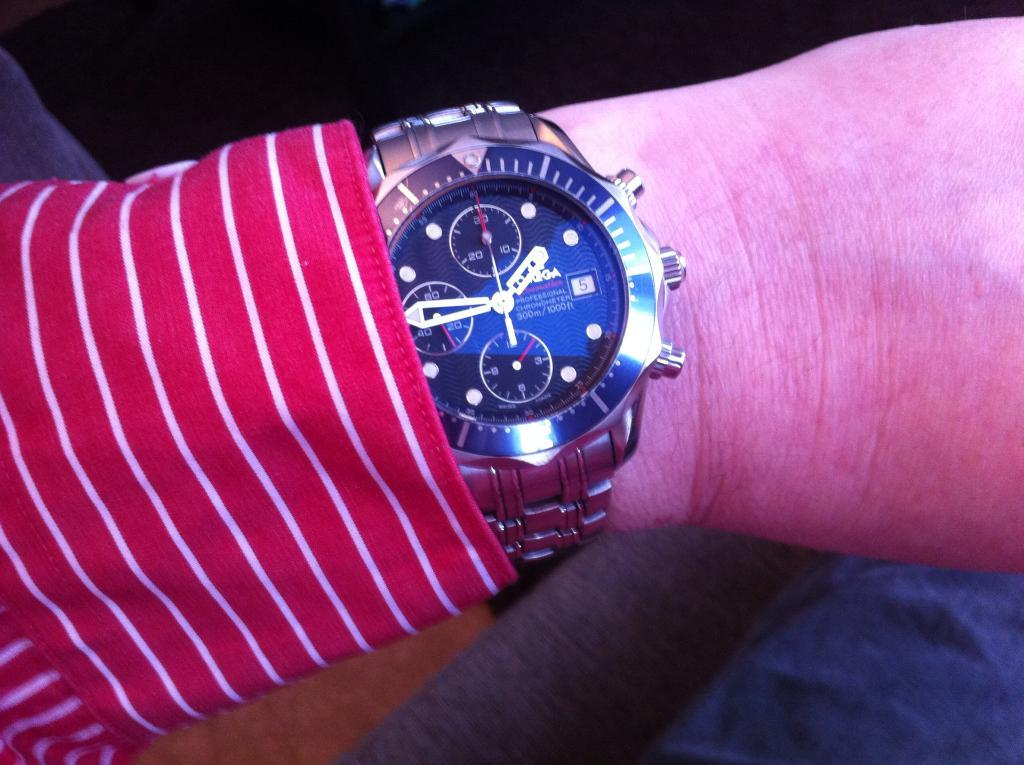<image>
Describe the image concisely. Face of a watch which says 1000ft on it. 